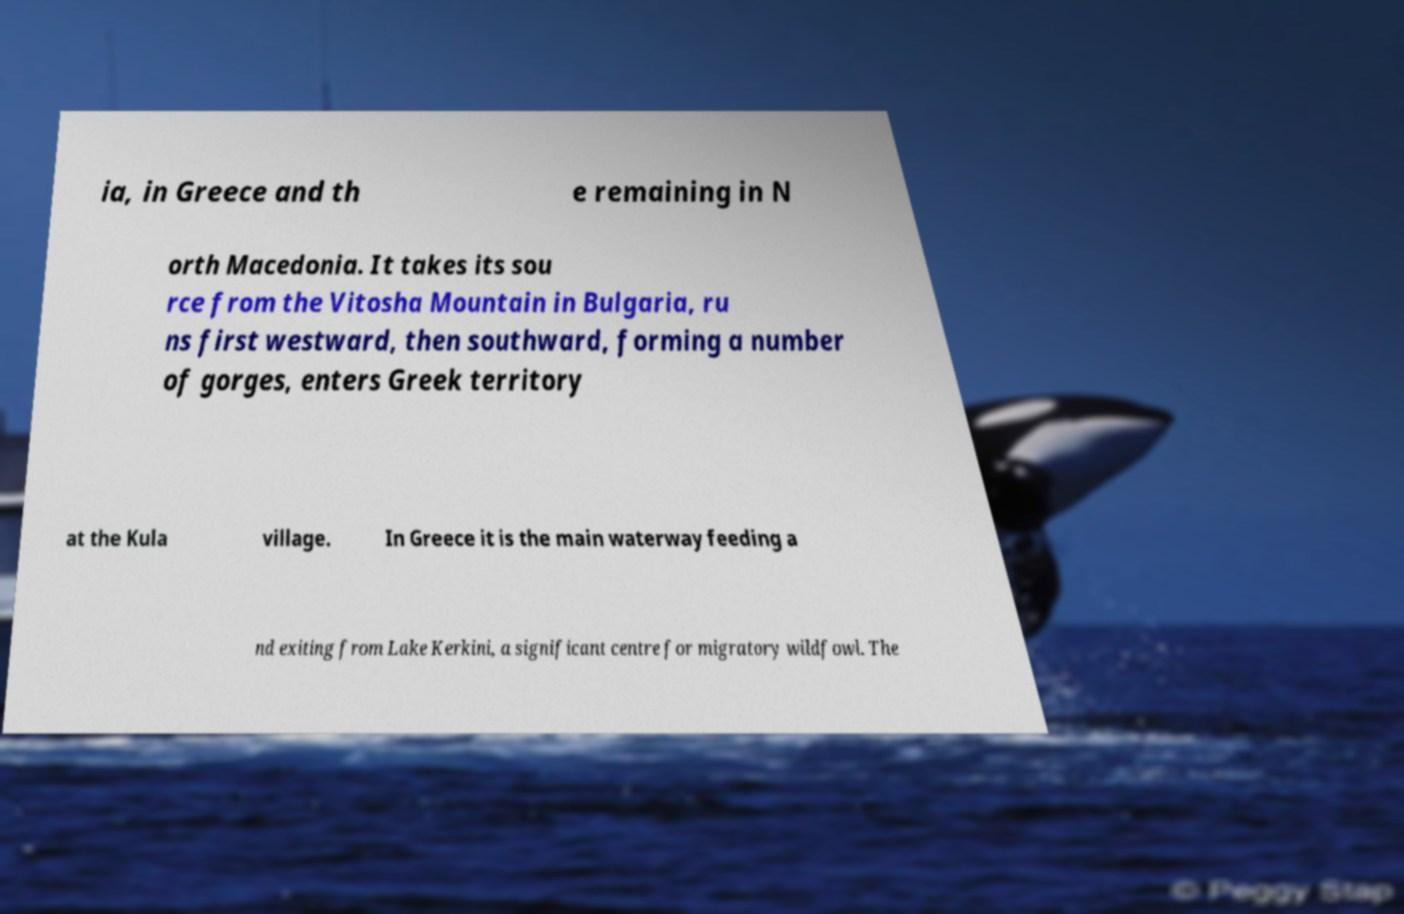Please read and relay the text visible in this image. What does it say? ia, in Greece and th e remaining in N orth Macedonia. It takes its sou rce from the Vitosha Mountain in Bulgaria, ru ns first westward, then southward, forming a number of gorges, enters Greek territory at the Kula village. In Greece it is the main waterway feeding a nd exiting from Lake Kerkini, a significant centre for migratory wildfowl. The 